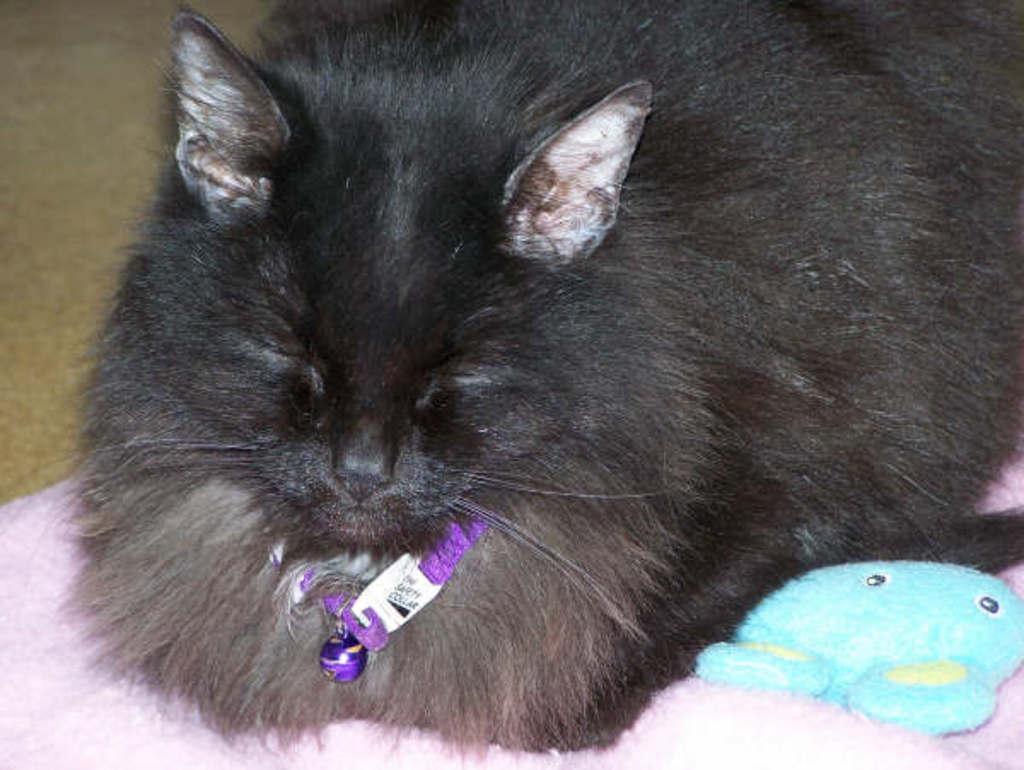Can you describe this image briefly? In this image we can see a black color cat on the pink color surface. There is an object in the right bottom of the image. We can see a purple color collar around the neck of the cat. It seems like a brown color cloth on the left side of the image. 